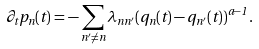<formula> <loc_0><loc_0><loc_500><loc_500>\partial _ { t } p _ { n } ( t ) = - \sum _ { n ^ { \prime } \ne n } \lambda _ { n n ^ { \prime } } ( q _ { n } ( t ) - q _ { n ^ { \prime } } ( t ) ) ^ { a - 1 } \, .</formula> 